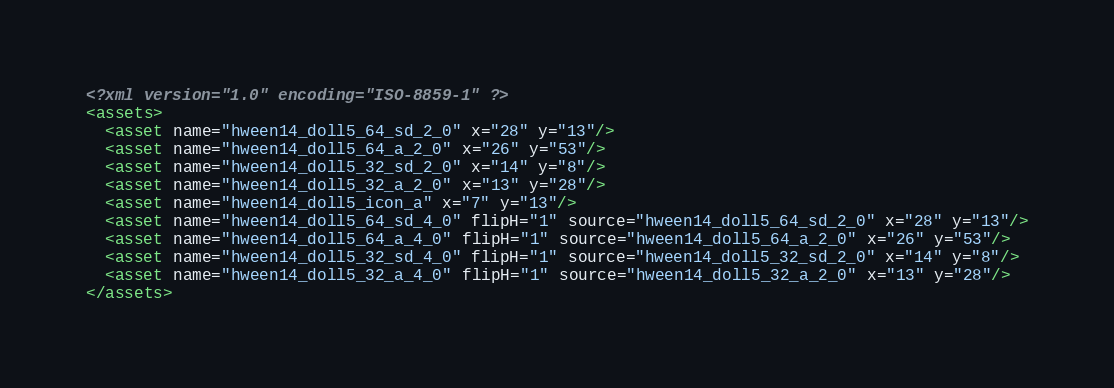<code> <loc_0><loc_0><loc_500><loc_500><_XML_><?xml version="1.0" encoding="ISO-8859-1" ?><assets>
  <asset name="hween14_doll5_64_sd_2_0" x="28" y="13"/>
  <asset name="hween14_doll5_64_a_2_0" x="26" y="53"/>
  <asset name="hween14_doll5_32_sd_2_0" x="14" y="8"/>
  <asset name="hween14_doll5_32_a_2_0" x="13" y="28"/>
  <asset name="hween14_doll5_icon_a" x="7" y="13"/>
  <asset name="hween14_doll5_64_sd_4_0" flipH="1" source="hween14_doll5_64_sd_2_0" x="28" y="13"/>
  <asset name="hween14_doll5_64_a_4_0" flipH="1" source="hween14_doll5_64_a_2_0" x="26" y="53"/>
  <asset name="hween14_doll5_32_sd_4_0" flipH="1" source="hween14_doll5_32_sd_2_0" x="14" y="8"/>
  <asset name="hween14_doll5_32_a_4_0" flipH="1" source="hween14_doll5_32_a_2_0" x="13" y="28"/>
</assets></code> 